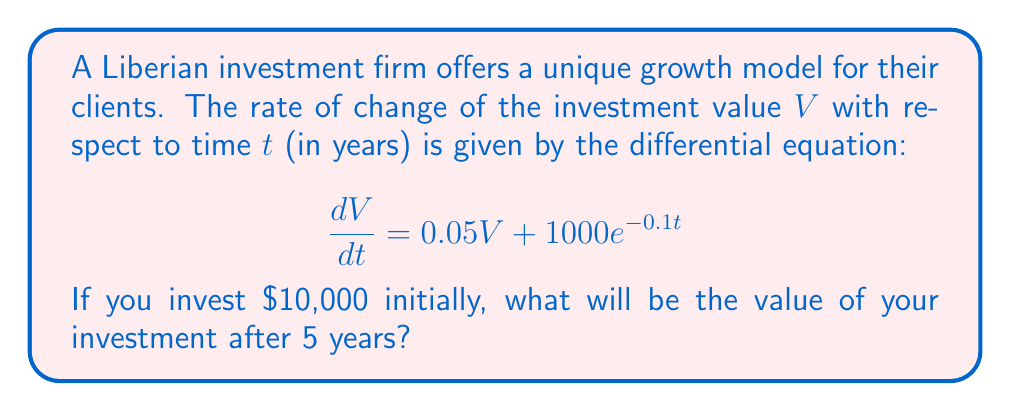Can you answer this question? To solve this problem, we need to follow these steps:

1) The given differential equation is:
   $$\frac{dV}{dt} = 0.05V + 1000e^{-0.1t}$$

2) This is a linear first-order differential equation. We can solve it using the integrating factor method.

3) The integrating factor is $e^{\int 0.05 dt} = e^{0.05t}$

4) Multiplying both sides of the equation by the integrating factor:
   $$e^{0.05t}\frac{dV}{dt} = 0.05Ve^{0.05t} + 1000e^{-0.1t}e^{0.05t}$$

5) The left side can be rewritten as $\frac{d}{dt}(Ve^{0.05t})$, so:
   $$\frac{d}{dt}(Ve^{0.05t}) = 1000e^{-0.05t}$$

6) Integrating both sides:
   $$Ve^{0.05t} = -20000e^{-0.05t} + C$$

7) Solving for V:
   $$V = -20000e^{-0.1t} + Ce^{-0.05t}$$

8) Using the initial condition $V(0) = 10000$:
   $$10000 = -20000 + C$$
   $$C = 30000$$

9) Therefore, the general solution is:
   $$V = -20000e^{-0.1t} + 30000e^{-0.05t}$$

10) To find the value after 5 years, we substitute $t = 5$:
    $$V(5) = -20000e^{-0.5} + 30000e^{-0.25}$$

11) Calculating this value:
    $$V(5) = -12052.40 + 23533.53 = 11481.13$$

Therefore, after 5 years, the investment will be worth approximately $11,481.13.
Answer: $11,481.13 